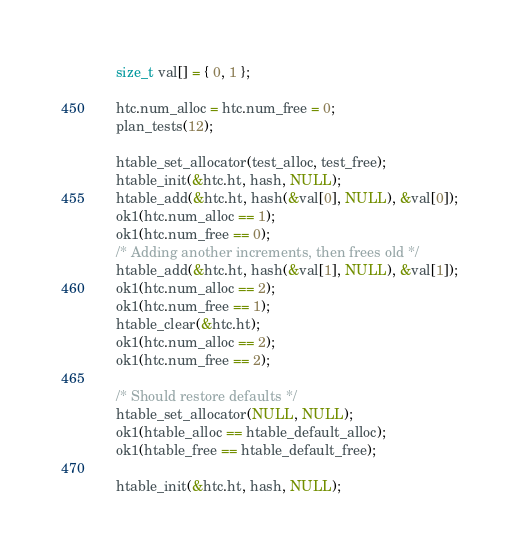<code> <loc_0><loc_0><loc_500><loc_500><_C_>	size_t val[] = { 0, 1 };

	htc.num_alloc = htc.num_free = 0;
	plan_tests(12);

	htable_set_allocator(test_alloc, test_free);
	htable_init(&htc.ht, hash, NULL);
	htable_add(&htc.ht, hash(&val[0], NULL), &val[0]);
	ok1(htc.num_alloc == 1);
	ok1(htc.num_free == 0);
	/* Adding another increments, then frees old */
	htable_add(&htc.ht, hash(&val[1], NULL), &val[1]);
	ok1(htc.num_alloc == 2);
	ok1(htc.num_free == 1);
	htable_clear(&htc.ht);
	ok1(htc.num_alloc == 2);
	ok1(htc.num_free == 2);

	/* Should restore defaults */
	htable_set_allocator(NULL, NULL);
	ok1(htable_alloc == htable_default_alloc);
	ok1(htable_free == htable_default_free);

	htable_init(&htc.ht, hash, NULL);</code> 